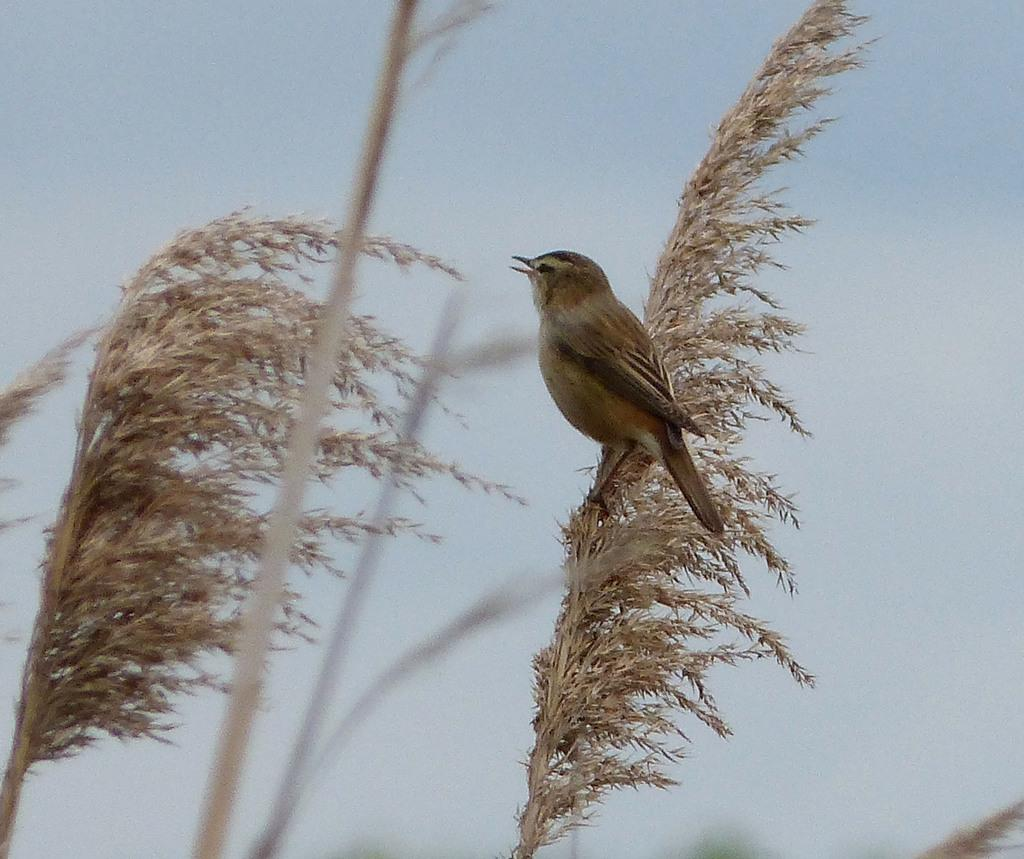What type of straws are present in the image? There are plant straws in the image. What animal can be seen in the image? There is a bird in the image. Where is the bird located in the image? The bird is on the plant straws. What is visible at the top of the image? The sky is visible at the top of the image. What type of powder can be seen falling from the sky in the image? There is no powder falling from the sky in the image; only the bird, plant straws, and sky are present. What is the smell of the image? The image does not have a smell; it is a visual representation. 